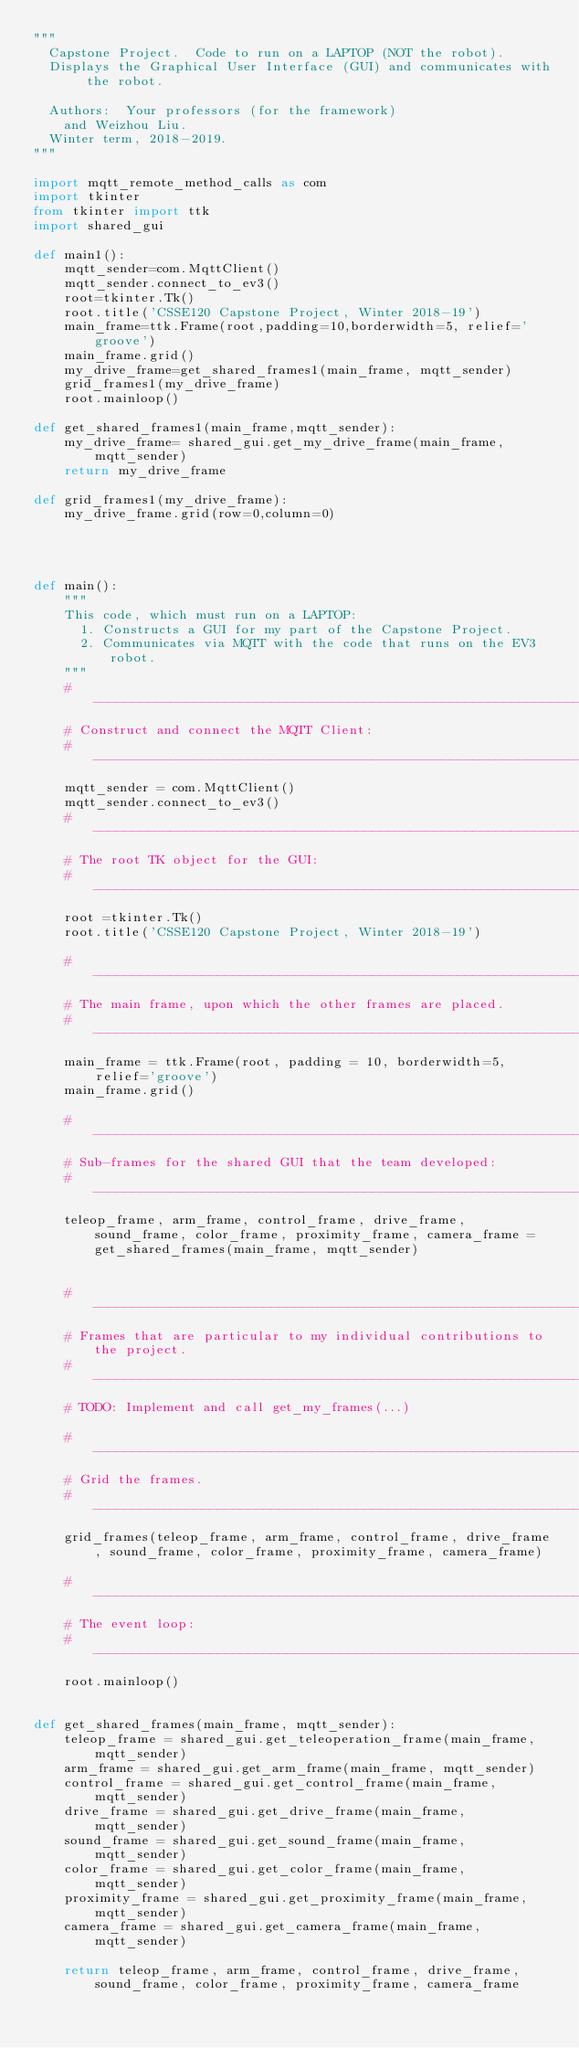Convert code to text. <code><loc_0><loc_0><loc_500><loc_500><_Python_>"""
  Capstone Project.  Code to run on a LAPTOP (NOT the robot).
  Displays the Graphical User Interface (GUI) and communicates with the robot.

  Authors:  Your professors (for the framework)
    and Weizhou Liu.
  Winter term, 2018-2019.
"""

import mqtt_remote_method_calls as com
import tkinter
from tkinter import ttk
import shared_gui

def main1():
    mqtt_sender=com.MqttClient()
    mqtt_sender.connect_to_ev3()
    root=tkinter.Tk()
    root.title('CSSE120 Capstone Project, Winter 2018-19')
    main_frame=ttk.Frame(root,padding=10,borderwidth=5, relief='groove')
    main_frame.grid()
    my_drive_frame=get_shared_frames1(main_frame, mqtt_sender)
    grid_frames1(my_drive_frame)
    root.mainloop()

def get_shared_frames1(main_frame,mqtt_sender):
    my_drive_frame= shared_gui.get_my_drive_frame(main_frame,mqtt_sender)
    return my_drive_frame

def grid_frames1(my_drive_frame):
    my_drive_frame.grid(row=0,column=0)




def main():
    """
    This code, which must run on a LAPTOP:
      1. Constructs a GUI for my part of the Capstone Project.
      2. Communicates via MQTT with the code that runs on the EV3 robot.
    """
    # -------------------------------------------------------------------------
    # Construct and connect the MQTT Client:
    # -------------------------------------------------------------------------
    mqtt_sender = com.MqttClient()
    mqtt_sender.connect_to_ev3()
    # -------------------------------------------------------------------------
    # The root TK object for the GUI:
    # -------------------------------------------------------------------------
    root =tkinter.Tk()
    root.title('CSSE120 Capstone Project, Winter 2018-19')

    # -------------------------------------------------------------------------
    # The main frame, upon which the other frames are placed.
    # -------------------------------------------------------------------------
    main_frame = ttk.Frame(root, padding = 10, borderwidth=5, relief='groove')
    main_frame.grid()

    # -------------------------------------------------------------------------
    # Sub-frames for the shared GUI that the team developed:
    # -------------------------------------------------------------------------
    teleop_frame, arm_frame, control_frame, drive_frame, sound_frame, color_frame, proximity_frame, camera_frame = get_shared_frames(main_frame, mqtt_sender)


    # -------------------------------------------------------------------------
    # Frames that are particular to my individual contributions to the project.
    # -------------------------------------------------------------------------
    # TODO: Implement and call get_my_frames(...)

    # -------------------------------------------------------------------------
    # Grid the frames.
    # -------------------------------------------------------------------------
    grid_frames(teleop_frame, arm_frame, control_frame, drive_frame, sound_frame, color_frame, proximity_frame, camera_frame)

    # -------------------------------------------------------------------------
    # The event loop:
    # -------------------------------------------------------------------------
    root.mainloop()


def get_shared_frames(main_frame, mqtt_sender):
    teleop_frame = shared_gui.get_teleoperation_frame(main_frame, mqtt_sender)
    arm_frame = shared_gui.get_arm_frame(main_frame, mqtt_sender)
    control_frame = shared_gui.get_control_frame(main_frame, mqtt_sender)
    drive_frame = shared_gui.get_drive_frame(main_frame, mqtt_sender)
    sound_frame = shared_gui.get_sound_frame(main_frame, mqtt_sender)
    color_frame = shared_gui.get_color_frame(main_frame, mqtt_sender)
    proximity_frame = shared_gui.get_proximity_frame(main_frame, mqtt_sender)
    camera_frame = shared_gui.get_camera_frame(main_frame, mqtt_sender)

    return teleop_frame, arm_frame, control_frame, drive_frame, sound_frame, color_frame, proximity_frame, camera_frame
</code> 